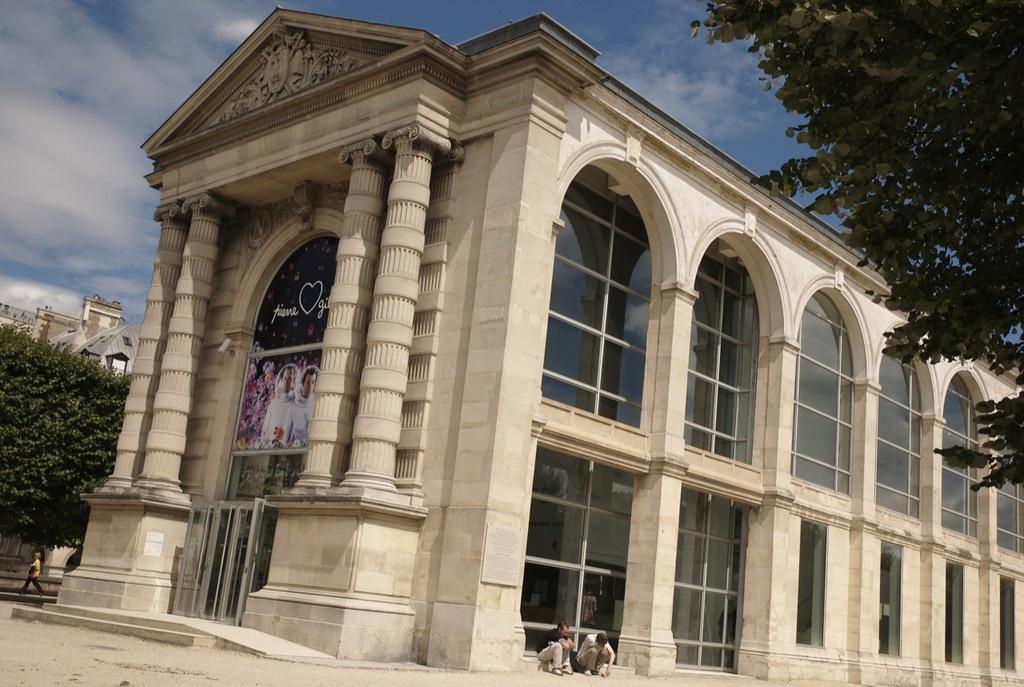What type of structures can be seen in the image? There are buildings in the image. What architectural features are visible on the buildings? There are windows and at least one door visible on the buildings. What type of vegetation is present in the image? There are trees in the image. What is visible in the sky in the image? The sky is visible in the image, and there are clouds present. What are the people in the image doing? The people sitting in the front of the image are likely resting or taking a break. What type of heat source is being used by the people sitting in the image? There is no heat source mentioned or visible in the image; the people are simply sitting. What scientific experiments are being conducted in the image? There is no indication of any scientific experiments being conducted in the image. 